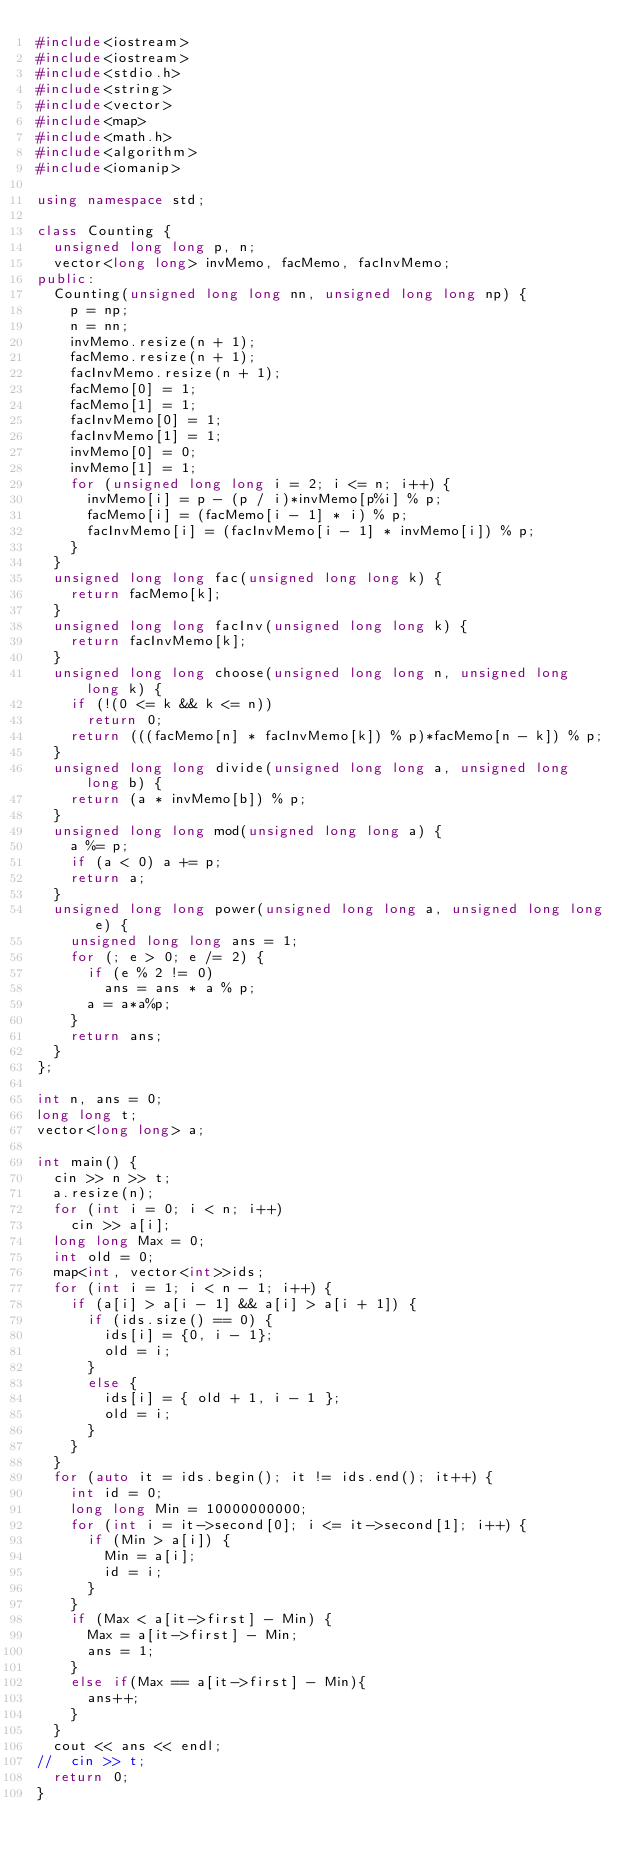Convert code to text. <code><loc_0><loc_0><loc_500><loc_500><_C++_>#include<iostream>
#include<iostream>
#include<stdio.h>
#include<string>
#include<vector>
#include<map>
#include<math.h>
#include<algorithm>
#include<iomanip>

using namespace std;

class Counting {
	unsigned long long p, n;
	vector<long long> invMemo, facMemo, facInvMemo;
public:
	Counting(unsigned long long nn, unsigned long long np) {
		p = np;
		n = nn;
		invMemo.resize(n + 1);
		facMemo.resize(n + 1);
		facInvMemo.resize(n + 1);
		facMemo[0] = 1;
		facMemo[1] = 1;
		facInvMemo[0] = 1;
		facInvMemo[1] = 1;
		invMemo[0] = 0;
		invMemo[1] = 1;
		for (unsigned long long i = 2; i <= n; i++) {
			invMemo[i] = p - (p / i)*invMemo[p%i] % p;
			facMemo[i] = (facMemo[i - 1] * i) % p;
			facInvMemo[i] = (facInvMemo[i - 1] * invMemo[i]) % p;
		}
	}
	unsigned long long fac(unsigned long long k) {
		return facMemo[k];
	}
	unsigned long long facInv(unsigned long long k) {
		return facInvMemo[k];
	}
	unsigned long long choose(unsigned long long n, unsigned long long k) {
		if (!(0 <= k && k <= n))
			return 0;
		return (((facMemo[n] * facInvMemo[k]) % p)*facMemo[n - k]) % p;
	}
	unsigned long long divide(unsigned long long a, unsigned long long b) {
		return (a * invMemo[b]) % p;
	}
	unsigned long long mod(unsigned long long a) {
		a %= p;
		if (a < 0) a += p;
		return a;
	}
	unsigned long long power(unsigned long long a, unsigned long long e) {
		unsigned long long ans = 1;
		for (; e > 0; e /= 2) {
			if (e % 2 != 0)
				ans = ans * a % p;
			a = a*a%p;
		}
		return ans;
	}
};

int n, ans = 0;
long long t;
vector<long long> a;

int main() {
	cin >> n >> t;
	a.resize(n);
	for (int i = 0; i < n; i++)
		cin >> a[i];
	long long Max = 0;
	int old = 0;
	map<int, vector<int>>ids;
	for (int i = 1; i < n - 1; i++) {
		if (a[i] > a[i - 1] && a[i] > a[i + 1]) {
			if (ids.size() == 0) {
				ids[i] = {0, i - 1};
				old = i;
			}
			else {
				ids[i] = { old + 1, i - 1 };
				old = i;
			}
		}
	}
	for (auto it = ids.begin(); it != ids.end(); it++) {
		int id = 0;
		long long Min = 10000000000;
		for (int i = it->second[0]; i <= it->second[1]; i++) {
			if (Min > a[i]) {
				Min = a[i];
				id = i;
			}
		}
		if (Max < a[it->first] - Min) {
			Max = a[it->first] - Min;
			ans = 1;
		}
		else if(Max == a[it->first] - Min){
			ans++;
		}
	}
	cout << ans << endl;
//	cin >> t;
	return 0;
}</code> 